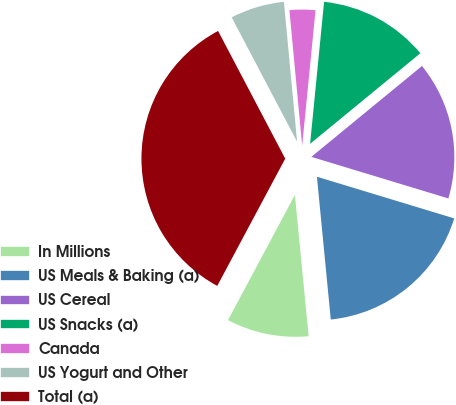Convert chart. <chart><loc_0><loc_0><loc_500><loc_500><pie_chart><fcel>In Millions<fcel>US Meals & Baking (a)<fcel>US Cereal<fcel>US Snacks (a)<fcel>Canada<fcel>US Yogurt and Other<fcel>Total (a)<nl><fcel>9.35%<fcel>18.77%<fcel>15.63%<fcel>12.49%<fcel>3.06%<fcel>6.21%<fcel>34.48%<nl></chart> 